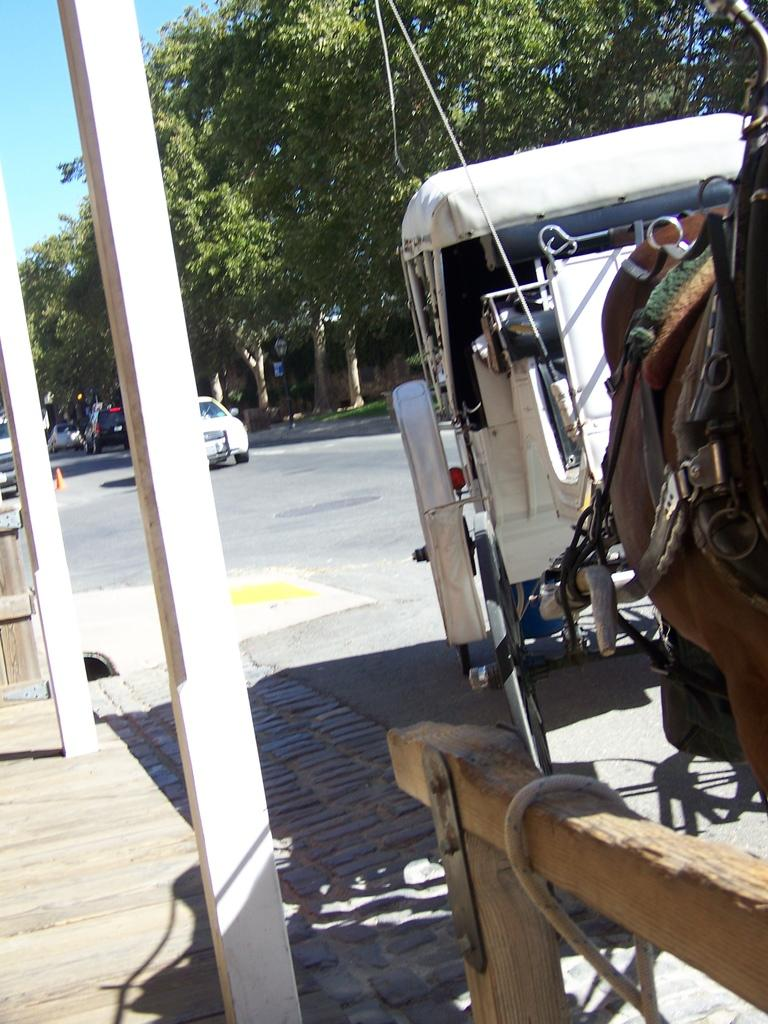What type of vehicle is in the image? There is a horse cart in the image. What else can be seen on the road in the image? There are cars on the road in the image. What can be seen in the background of the image? There are trees and sky visible in the background of the image. What objects are present in the image that might be used for support or guidance? There are poles in the image. What type of spoon is used to stir the trees in the image? There is no spoon present in the image, and trees do not require stirring. 